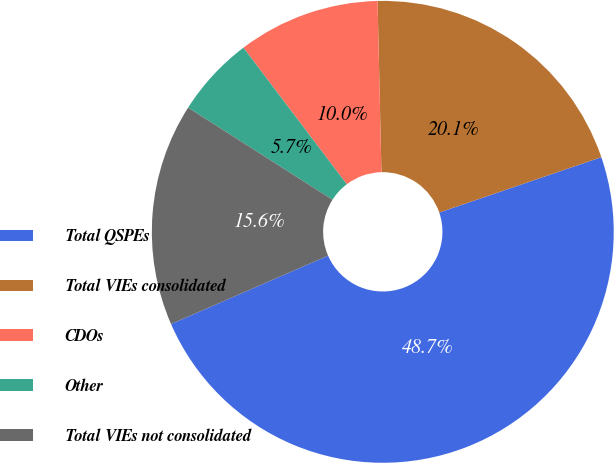<chart> <loc_0><loc_0><loc_500><loc_500><pie_chart><fcel>Total QSPEs<fcel>Total VIEs consolidated<fcel>CDOs<fcel>Other<fcel>Total VIEs not consolidated<nl><fcel>48.7%<fcel>20.12%<fcel>9.95%<fcel>5.65%<fcel>15.57%<nl></chart> 